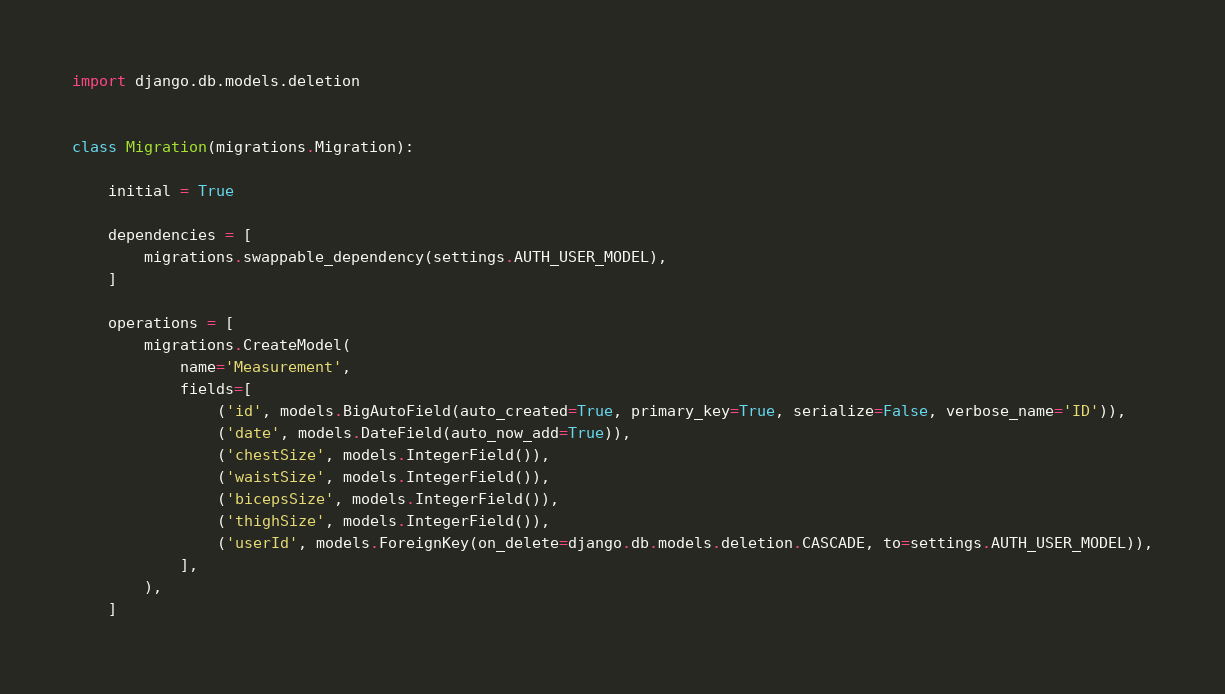Convert code to text. <code><loc_0><loc_0><loc_500><loc_500><_Python_>import django.db.models.deletion


class Migration(migrations.Migration):

    initial = True

    dependencies = [
        migrations.swappable_dependency(settings.AUTH_USER_MODEL),
    ]

    operations = [
        migrations.CreateModel(
            name='Measurement',
            fields=[
                ('id', models.BigAutoField(auto_created=True, primary_key=True, serialize=False, verbose_name='ID')),
                ('date', models.DateField(auto_now_add=True)),
                ('chestSize', models.IntegerField()),
                ('waistSize', models.IntegerField()),
                ('bicepsSize', models.IntegerField()),
                ('thighSize', models.IntegerField()),
                ('userId', models.ForeignKey(on_delete=django.db.models.deletion.CASCADE, to=settings.AUTH_USER_MODEL)),
            ],
        ),
    ]
</code> 